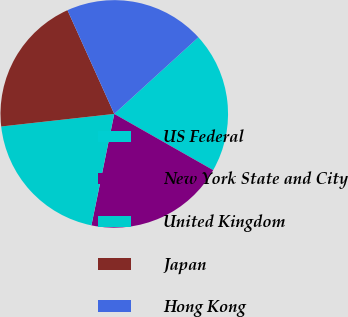Convert chart. <chart><loc_0><loc_0><loc_500><loc_500><pie_chart><fcel>US Federal<fcel>New York State and City<fcel>United Kingdom<fcel>Japan<fcel>Hong Kong<nl><fcel>19.99%<fcel>19.99%<fcel>20.02%<fcel>20.02%<fcel>19.99%<nl></chart> 